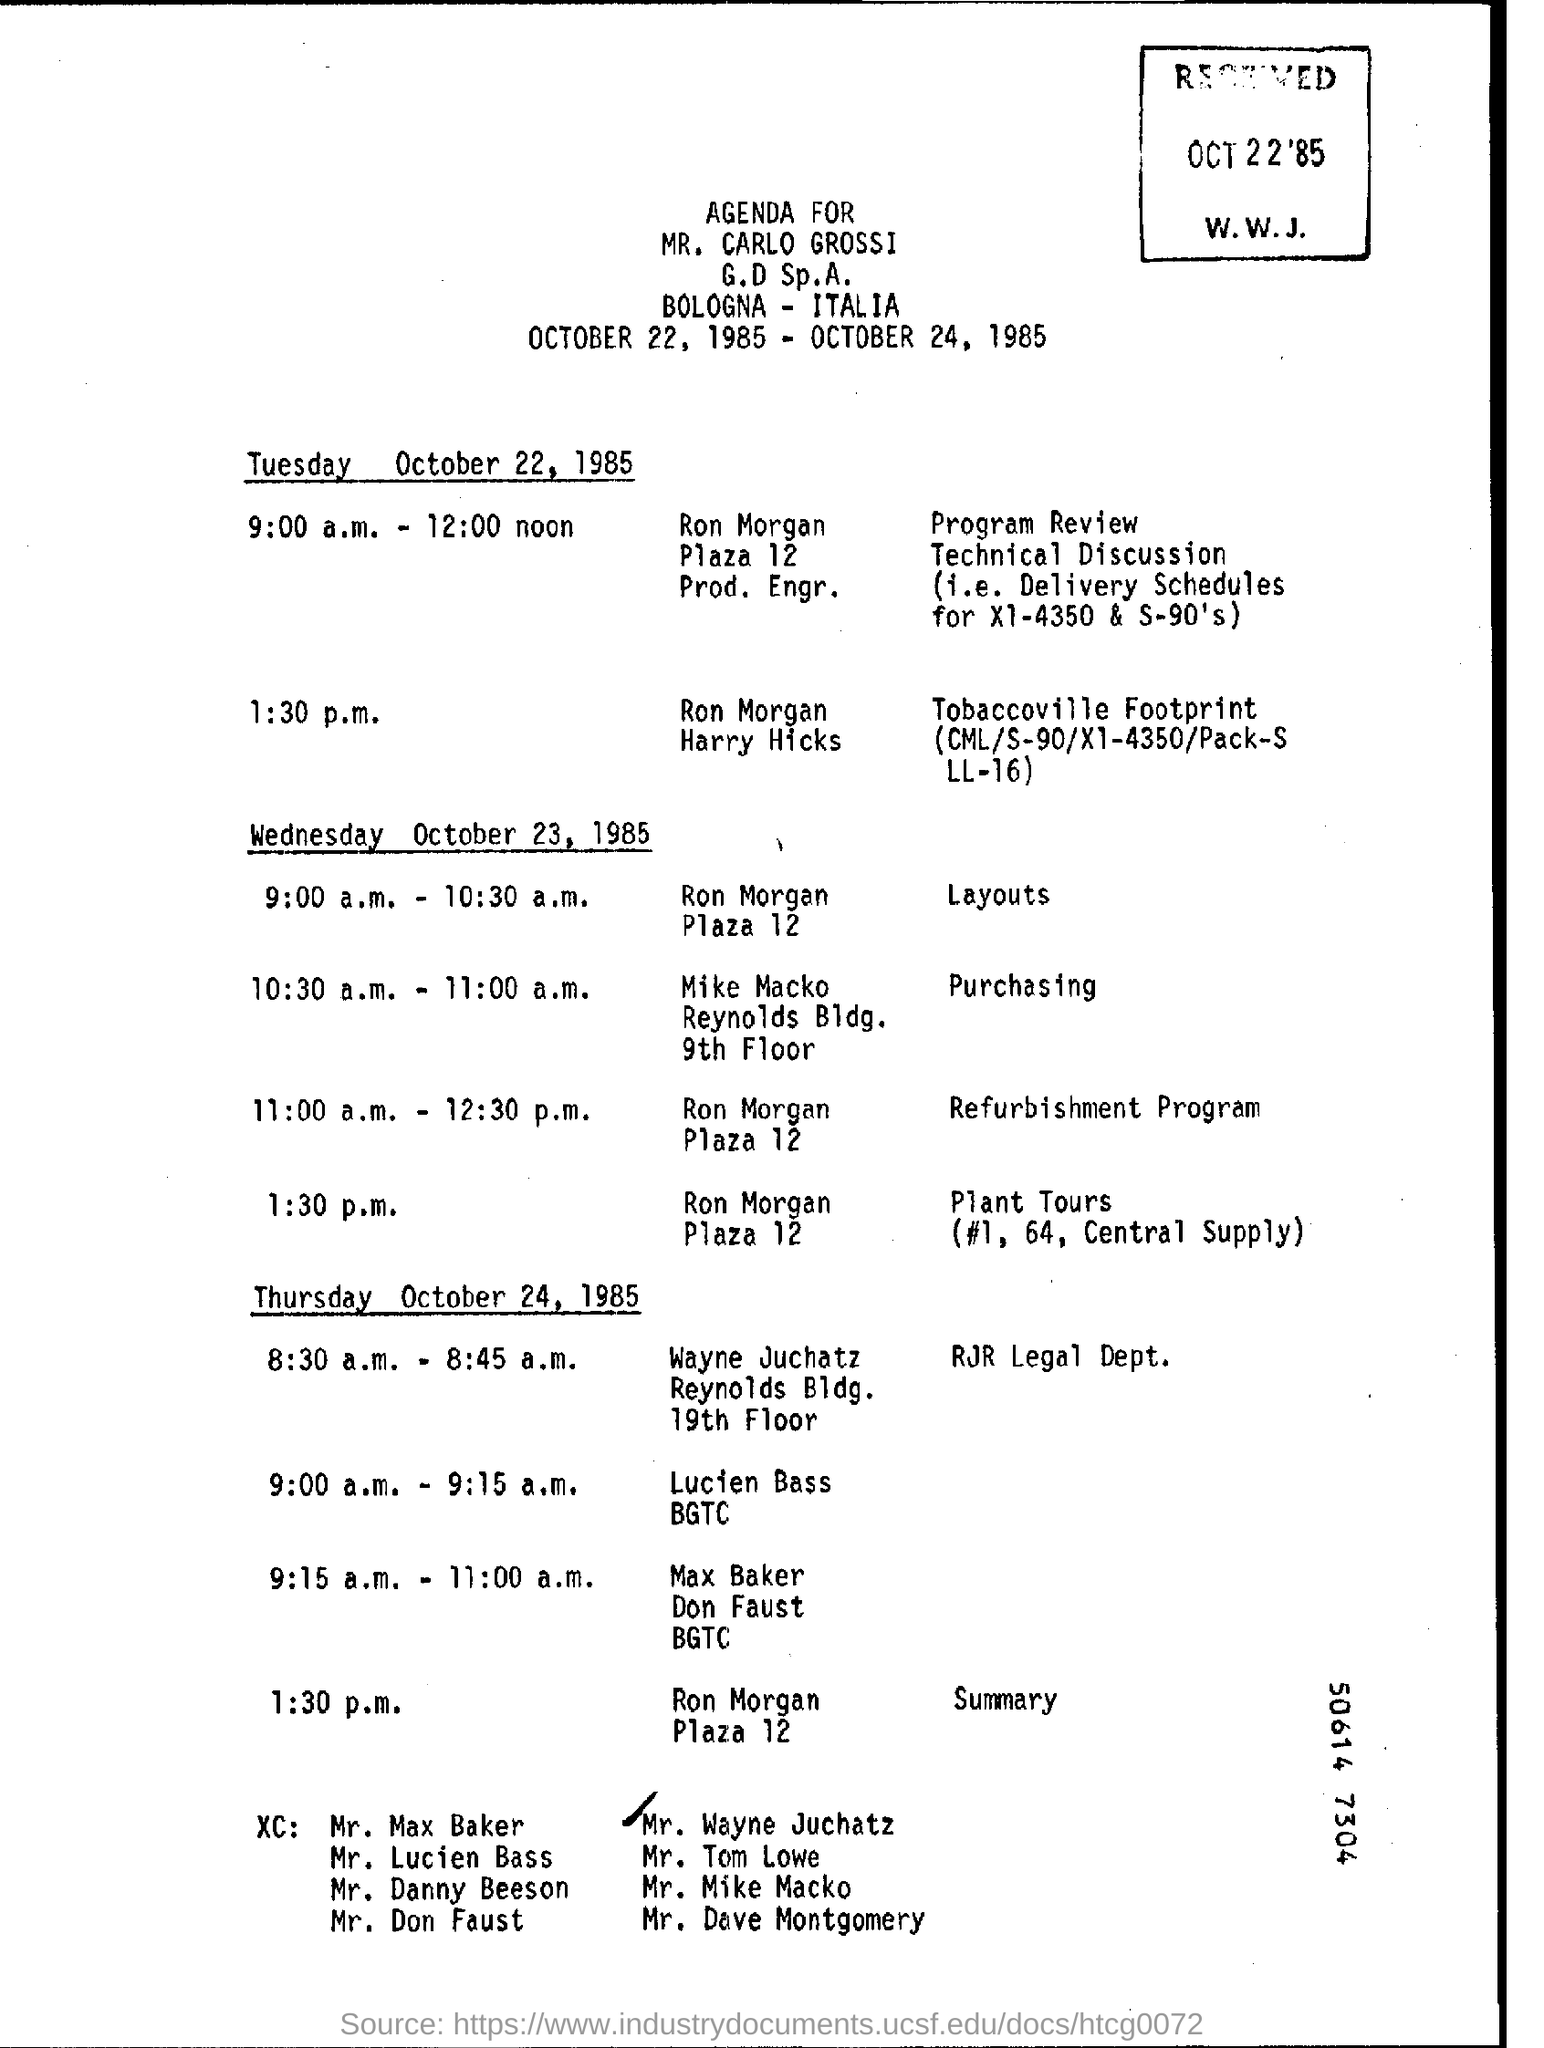Indicate a few pertinent items in this graphic. Purchasing will take place at 10:30 a.m. to 11:00 a.m. on Wednesday. On October 24, 1985, it was Thursday. On Tuesday, the "Program Review" will take place from 9:00 a.m. to 12:00 noon. Plant Tours will take place at 1:30 p.m. on Wednesday. At 1:30 p.m. on Thursday, the summary will be. 